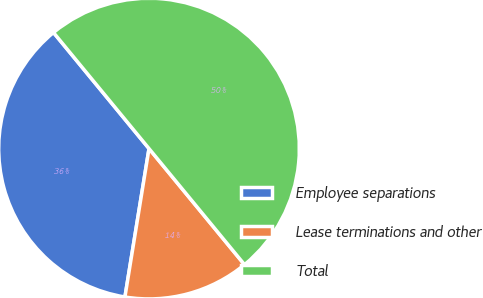<chart> <loc_0><loc_0><loc_500><loc_500><pie_chart><fcel>Employee separations<fcel>Lease terminations and other<fcel>Total<nl><fcel>36.48%<fcel>13.52%<fcel>50.0%<nl></chart> 